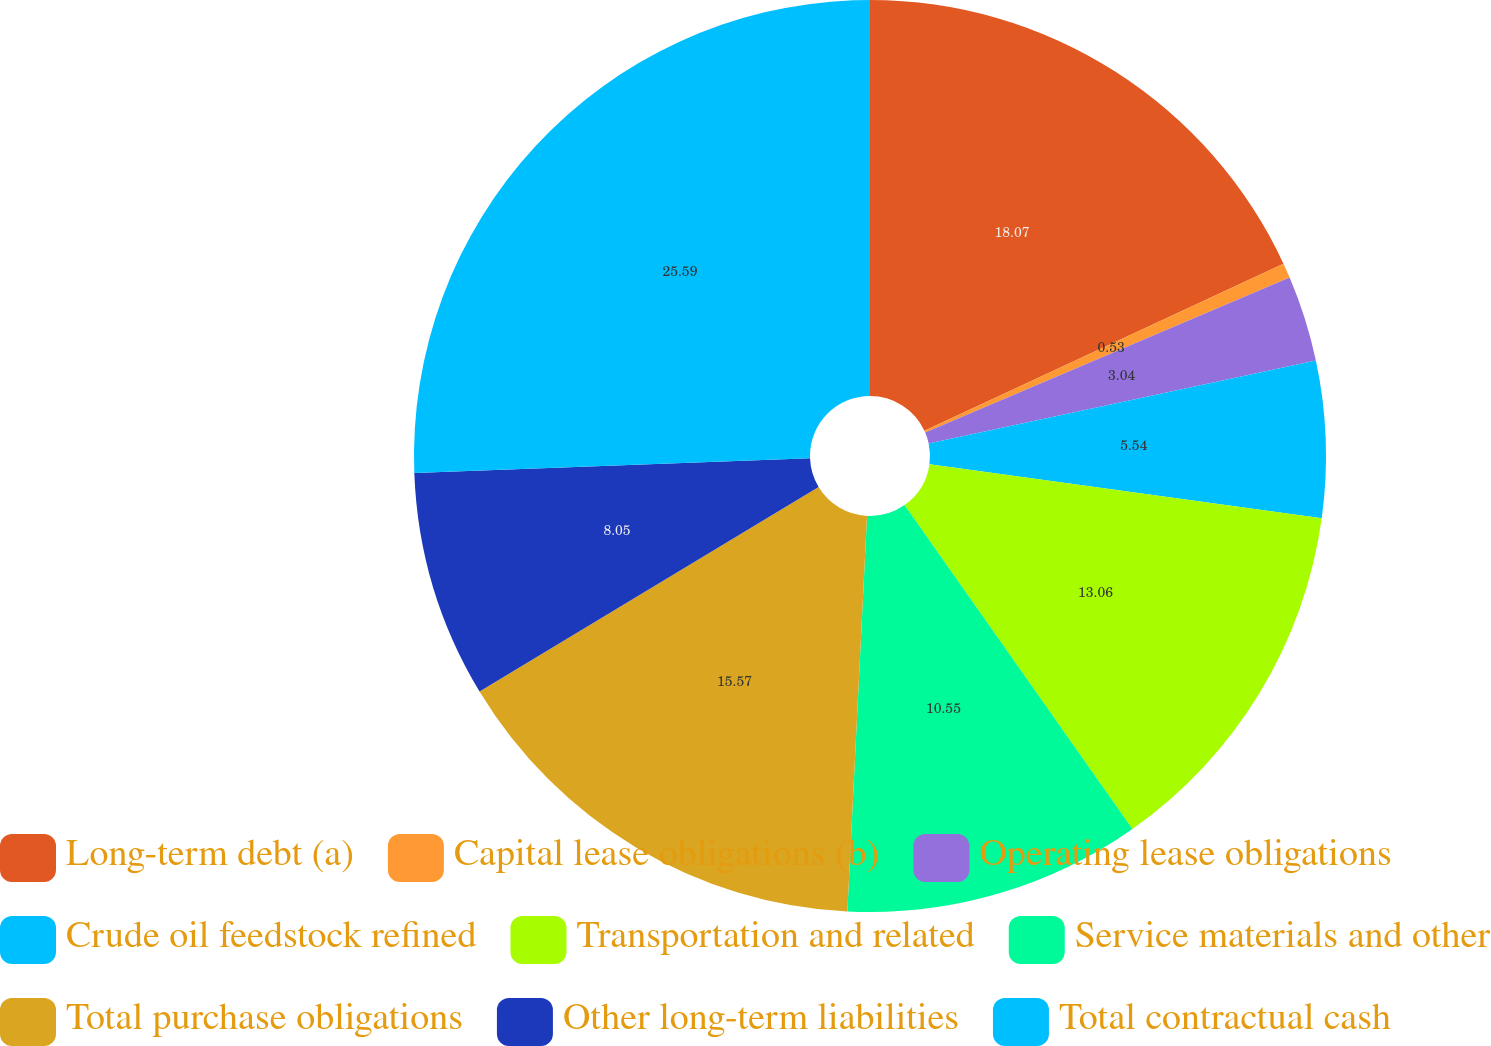Convert chart to OTSL. <chart><loc_0><loc_0><loc_500><loc_500><pie_chart><fcel>Long-term debt (a)<fcel>Capital lease obligations (b)<fcel>Operating lease obligations<fcel>Crude oil feedstock refined<fcel>Transportation and related<fcel>Service materials and other<fcel>Total purchase obligations<fcel>Other long-term liabilities<fcel>Total contractual cash<nl><fcel>18.07%<fcel>0.53%<fcel>3.04%<fcel>5.54%<fcel>13.06%<fcel>10.55%<fcel>15.57%<fcel>8.05%<fcel>25.59%<nl></chart> 